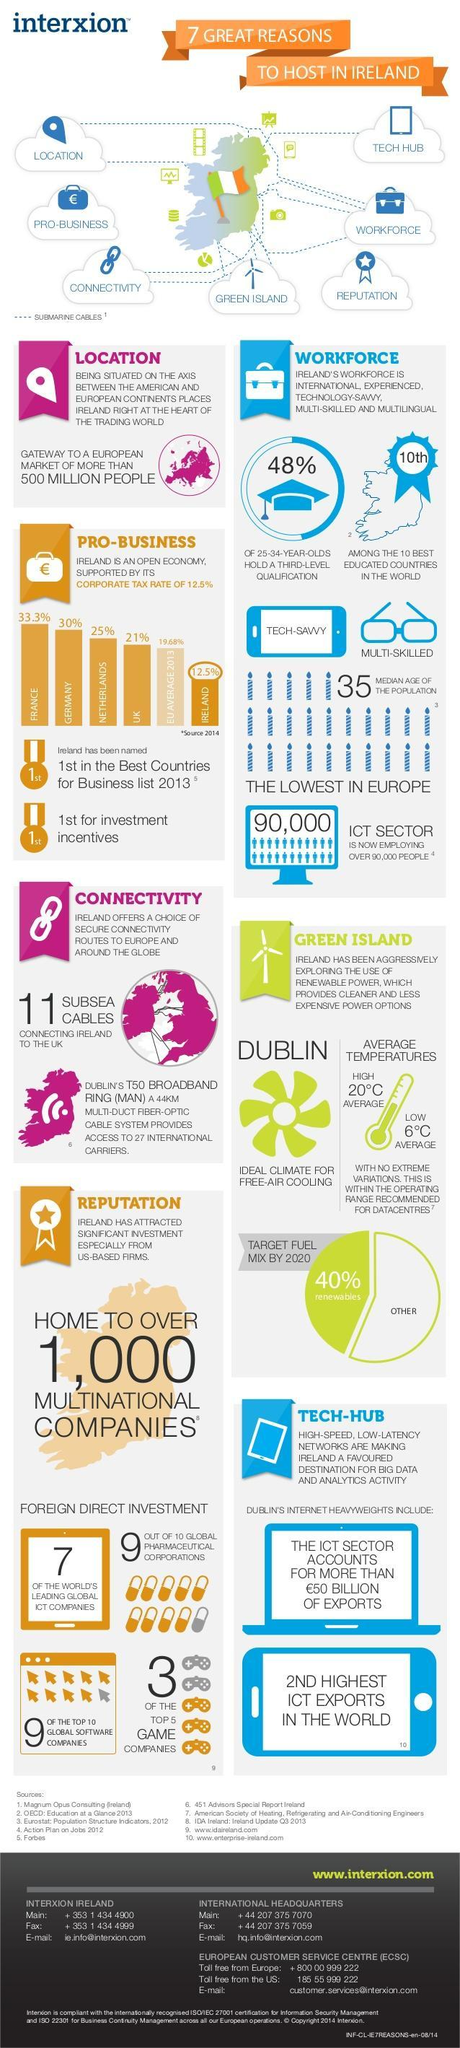What is average corporate tax rate of EU in 2013?
Answer the question with a short phrase. 19.68% What is corporate tax rate in Germany in 2014, 33.3%, 21%, or 30%? 30% Which country has a corporate tax rate of 25%, France, Netherlands, or UK? Netherlands 